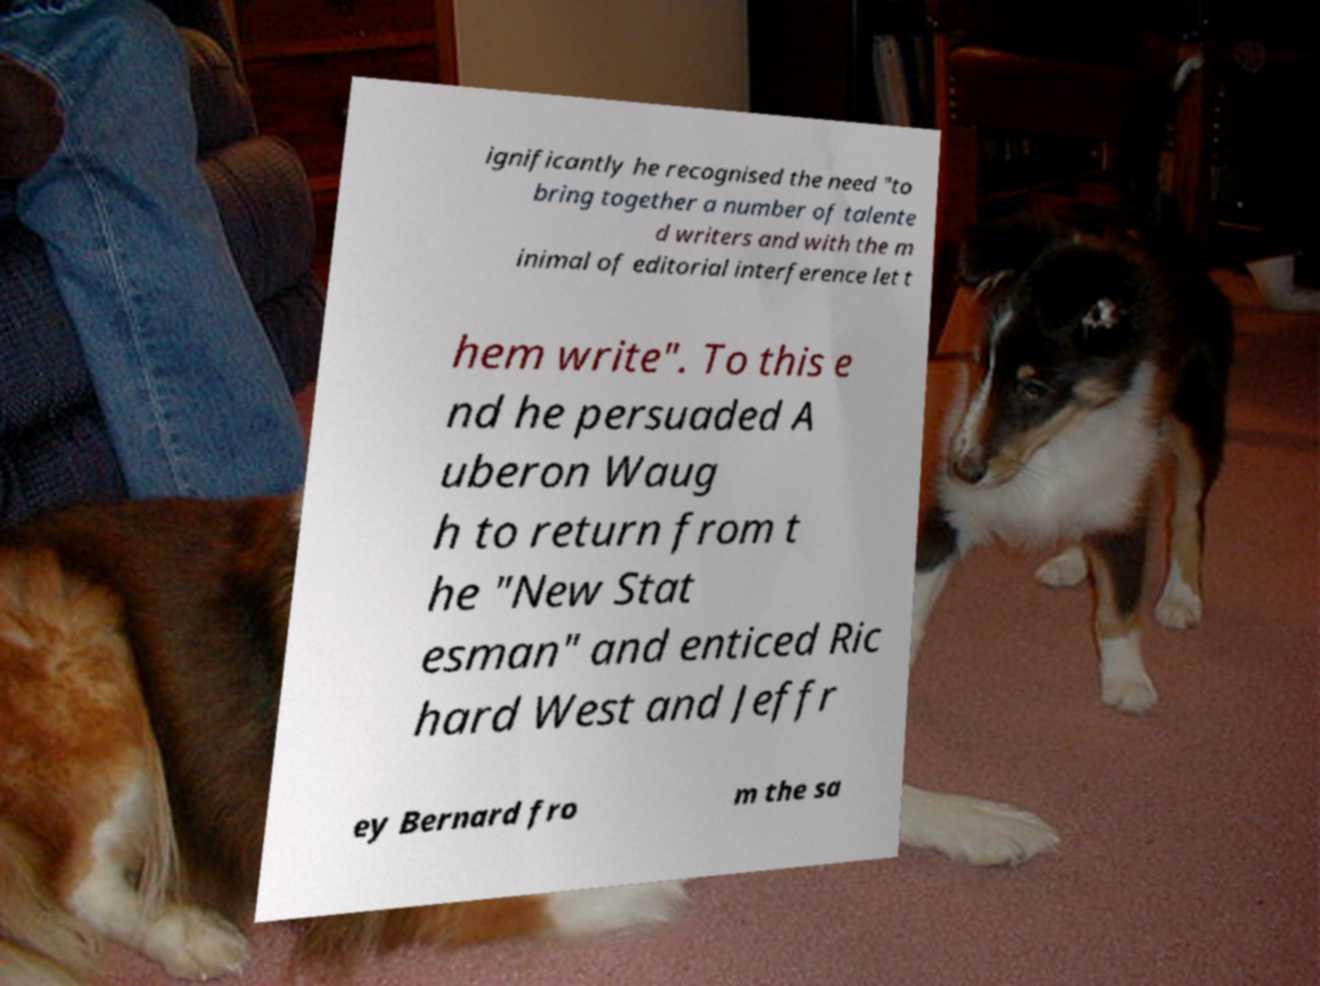Please read and relay the text visible in this image. What does it say? ignificantly he recognised the need "to bring together a number of talente d writers and with the m inimal of editorial interference let t hem write". To this e nd he persuaded A uberon Waug h to return from t he "New Stat esman" and enticed Ric hard West and Jeffr ey Bernard fro m the sa 